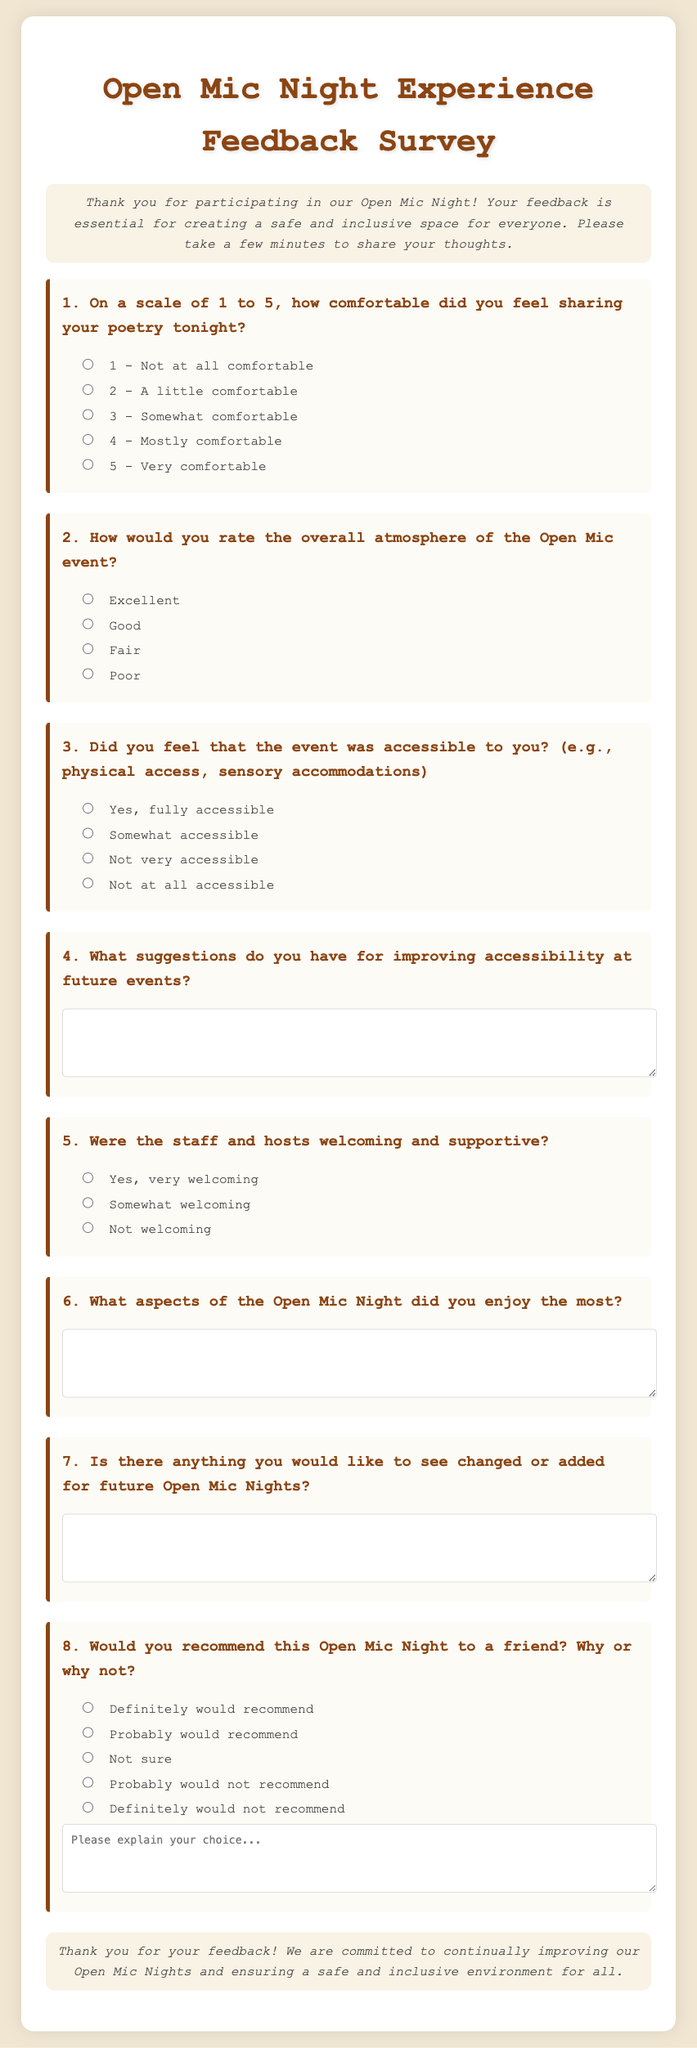What is the title of the document? The title of the document is presented at the top of the HTML code within the title tag, stating "Open Mic Night Experience Feedback Survey".
Answer: Open Mic Night Experience Feedback Survey How many questions are included in the survey? The survey contains a total of eight questions listed sequentially in the document.
Answer: 8 What is the first question about? The first question asks participants to rate their comfort level in sharing poetry on a scale of 1 to 5.
Answer: Comfort level sharing poetry What is the overall tone of the introduction? The introduction expresses gratitude and emphasizes the importance of feedback for creating a safe and inclusive space.
Answer: Appreciative and welcoming What type of response options are provided for question three? Question three includes radio buttons with options regarding the accessibility of the event.
Answer: Radio buttons What suggestion is sought from participants in question four? The fourth question invites participants to suggest improvements for accessibility at future events.
Answer: Improvements for accessibility How is participant feedback on the atmosphere collected? Feedback on the atmosphere is collected through a rating system with radio buttons from Excellent to Poor.
Answer: Rating system What question requires a written explanation in addition to the response options? The eighth question asks participants to explain their recommendation choice for the Open Mic Night.
Answer: Question eight Is there a closing statement in the document? Yes, there is a closing statement thanking the participants for their feedback and committed to improvement.
Answer: Yes, there is a closing statement 